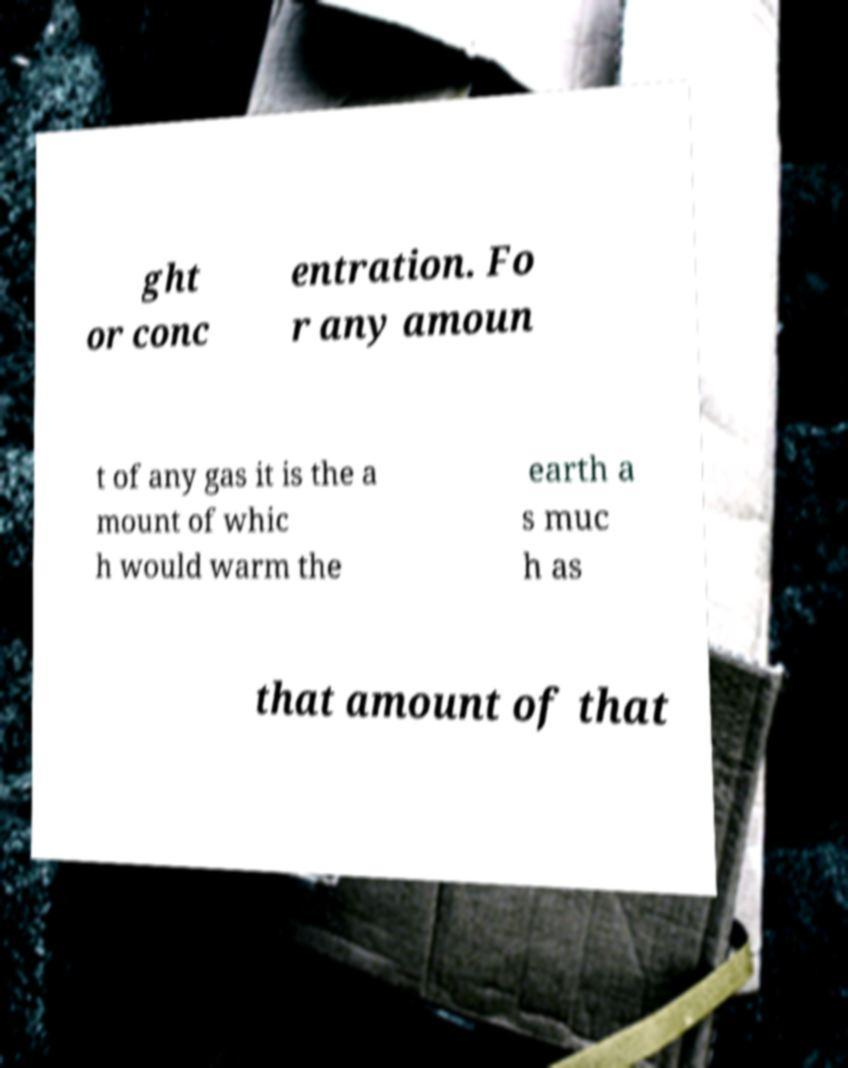What messages or text are displayed in this image? I need them in a readable, typed format. ght or conc entration. Fo r any amoun t of any gas it is the a mount of whic h would warm the earth a s muc h as that amount of that 